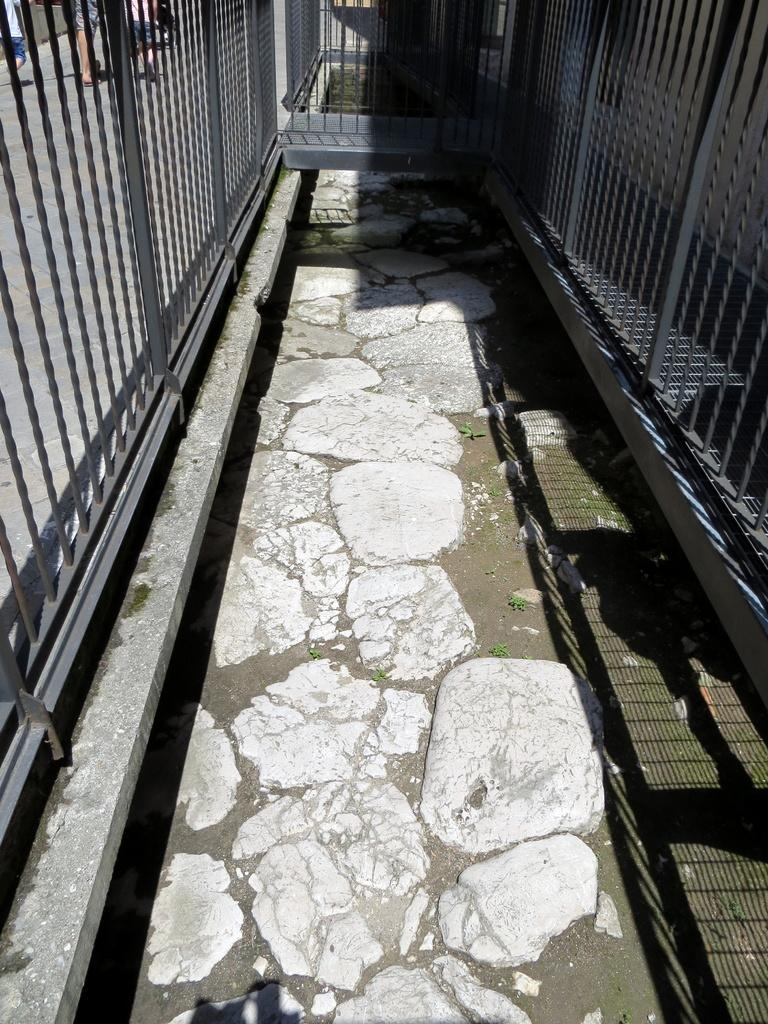What type of pathway is depicted in the image? There is a small lane in the image. What can be seen around the lane? The lane has black color fencing grill around it. What is on the ground in the image? There are white stones on the ground in the image. How does the boy's nerve affect his performance in the camp shown in the image? There is no boy or camp present in the image; it features a small lane with black color fencing grill and white stones on the ground. 